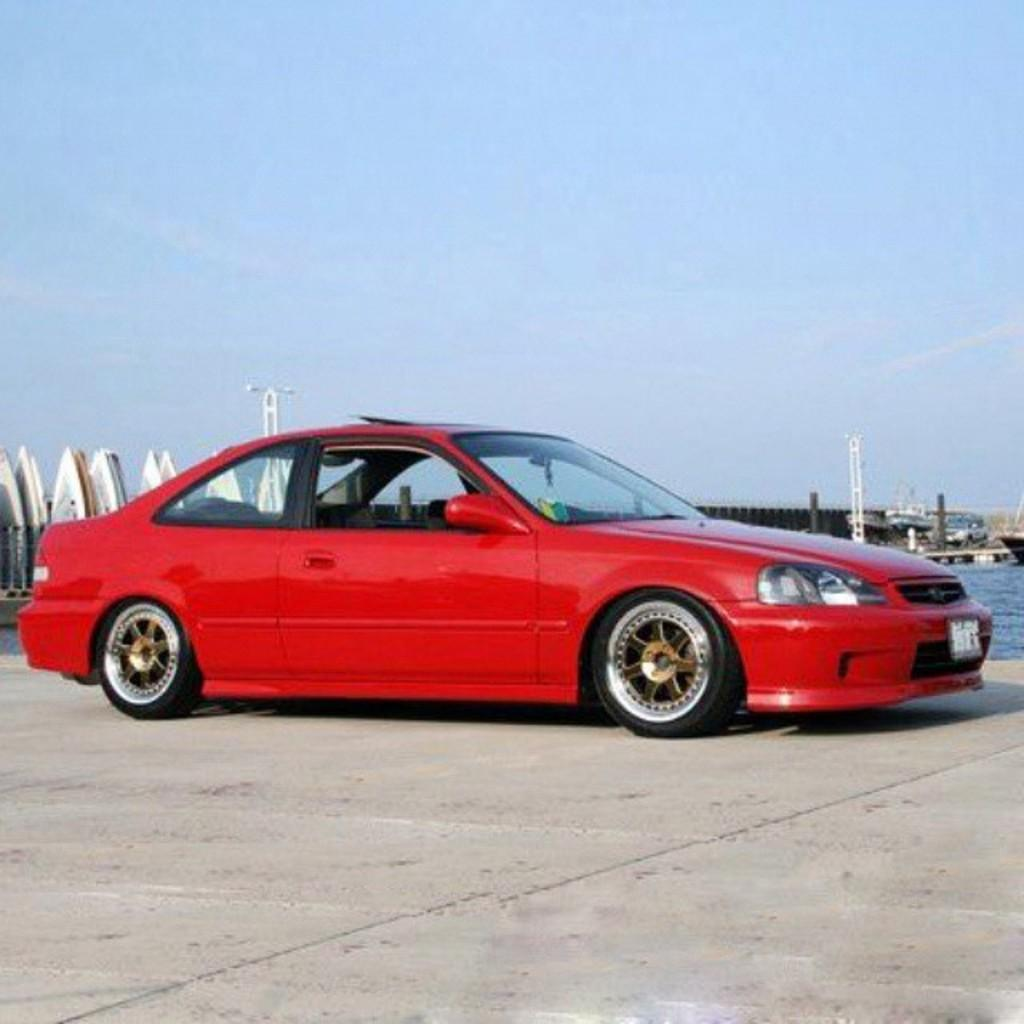What color is the car in the image? The car in the image is red. Where is the car located in the image? The car is parked on a path in the image. What can be seen in the background of the image? In the background of the image, there are poles, objects, vehicles, water, and the sky. What type of circle can be seen on the car's hood in the image? There is no circle visible on the car's hood in the image. 